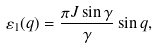<formula> <loc_0><loc_0><loc_500><loc_500>\varepsilon _ { 1 } ( q ) = \frac { \pi J \sin \gamma } { \gamma } \sin q ,</formula> 